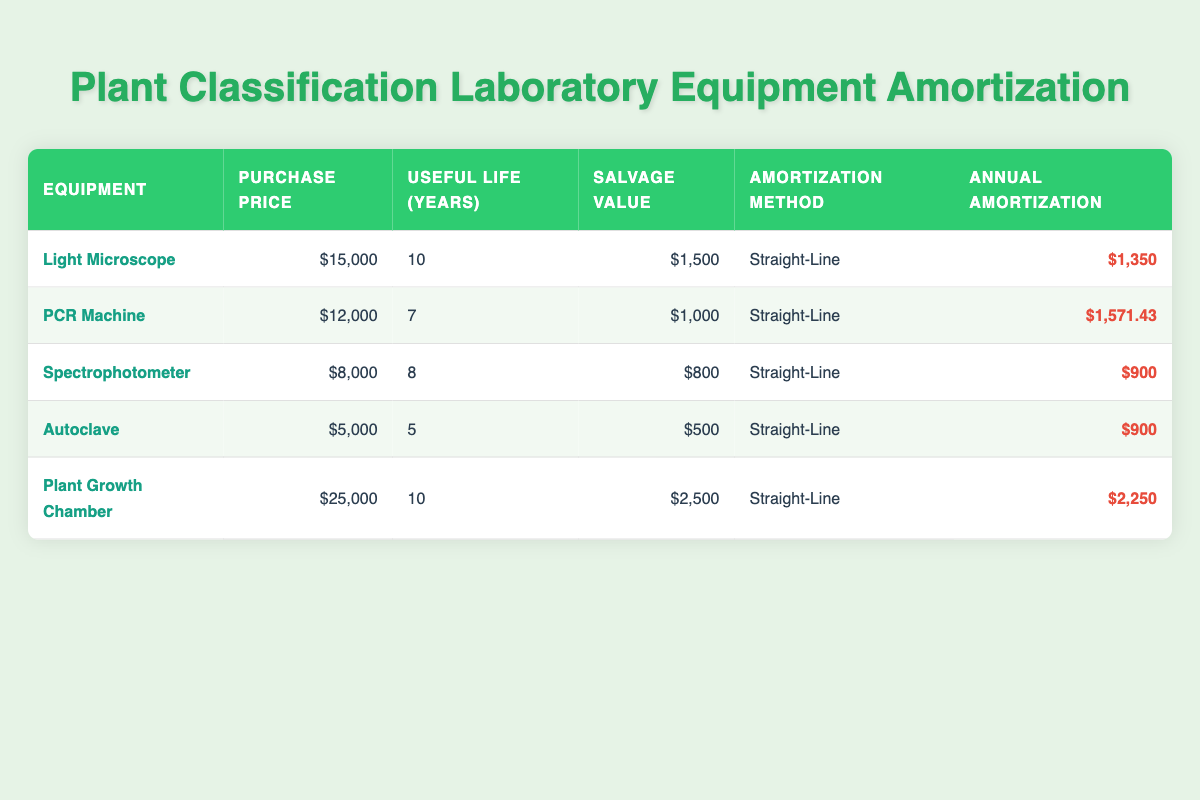What is the purchase price of the Light Microscope? The purchase price of the Light Microscope is listed in the table under the "Purchase Price" column. According to the data, it is $15,000.
Answer: $15,000 How long is the useful life of the PCR Machine? The useful life of the PCR Machine is shown in the "Useful Life (Years)" column. It is indicated as 7 years in the table.
Answer: 7 years Which equipment has the highest annual amortization? To find the equipment with the highest annual amortization, we can look at the "Annual Amortization" column and see that the Plant Growth Chamber has the highest value of $2,250.
Answer: Plant Growth Chamber What is the total salvage value of all the equipment? The salvage value for each piece of equipment needs to be summed up. Adding $1,500 (Light Microscope) + $1,000 (PCR Machine) + $800 (Spectrophotometer) + $500 (Autoclave) + $2,500 (Plant Growth Chamber) gives $6,300 as the total salvage value.
Answer: $6,300 Is the annual amortization of the Autoclave equal to that of the Spectrophotometer? We can compare the annual amortization of both units, which are $900 for the Autoclave and $900 for the Spectrophotometer. Since both values are equal, the statement is true.
Answer: Yes Which equipment has the lowest purchase price, and what is that price? Looking through the "Purchase Price" column, we see the Autoclave at $5,000, which is the lowest among all equipment listed in the table.
Answer: Autoclave, $5,000 What is the average annual amortization for all pieces of equipment? First, we need to sum the annual amortizations: $1,350 (Light Microscope) + $1,571.43 (PCR Machine) + $900 (Spectrophotometer) + $900 (Autoclave) + $2,250 (Plant Growth Chamber) = $8,971.43. There are 5 pieces of equipment, so the average is $8,971.43 / 5 = $1,794.29.
Answer: $1,794.29 Are all equipment items using the Straight-Line amortization method? We check the "Amortization Method" column for each equipment item and find that all listed items are indeed using the Straight-Line method. The answer to the question is true.
Answer: Yes Which equipment has the longest useful life, and what is its duration? By examining the "Useful Life (Years)" column, we find that both the Light Microscope and Plant Growth Chamber have a useful life of 10 years, which is the longest among the listed items.
Answer: Light Microscope and Plant Growth Chamber, 10 years 